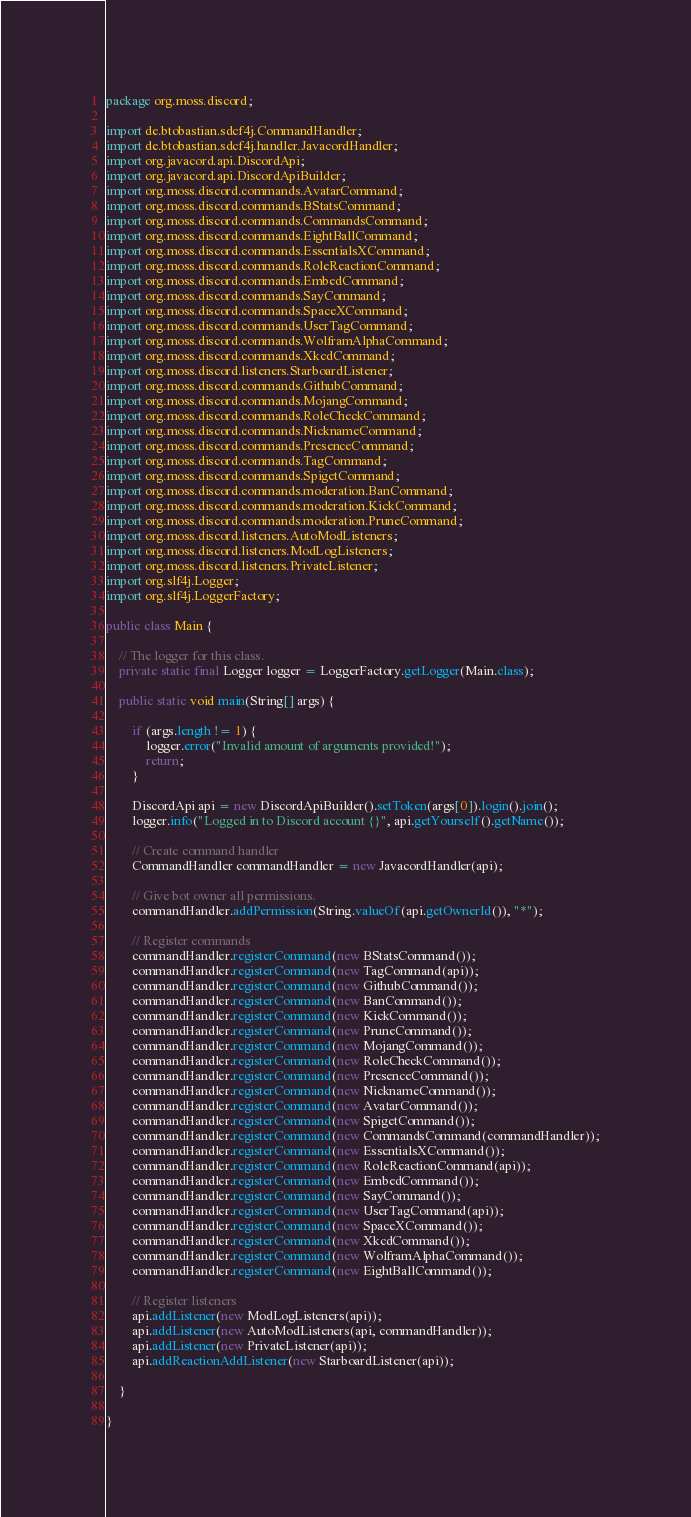Convert code to text. <code><loc_0><loc_0><loc_500><loc_500><_Java_>package org.moss.discord;

import de.btobastian.sdcf4j.CommandHandler;
import de.btobastian.sdcf4j.handler.JavacordHandler;
import org.javacord.api.DiscordApi;
import org.javacord.api.DiscordApiBuilder;
import org.moss.discord.commands.AvatarCommand;
import org.moss.discord.commands.BStatsCommand;
import org.moss.discord.commands.CommandsCommand;
import org.moss.discord.commands.EightBallCommand;
import org.moss.discord.commands.EssentialsXCommand;
import org.moss.discord.commands.RoleReactionCommand;
import org.moss.discord.commands.EmbedCommand;
import org.moss.discord.commands.SayCommand;
import org.moss.discord.commands.SpaceXCommand;
import org.moss.discord.commands.UserTagCommand;
import org.moss.discord.commands.WolframAlphaCommand;
import org.moss.discord.commands.XkcdCommand;
import org.moss.discord.listeners.StarboardListener;
import org.moss.discord.commands.GithubCommand;
import org.moss.discord.commands.MojangCommand;
import org.moss.discord.commands.RoleCheckCommand;
import org.moss.discord.commands.NicknameCommand;
import org.moss.discord.commands.PresenceCommand;
import org.moss.discord.commands.TagCommand;
import org.moss.discord.commands.SpigetCommand;
import org.moss.discord.commands.moderation.BanCommand;
import org.moss.discord.commands.moderation.KickCommand;
import org.moss.discord.commands.moderation.PruneCommand;
import org.moss.discord.listeners.AutoModListeners;
import org.moss.discord.listeners.ModLogListeners;
import org.moss.discord.listeners.PrivateListener;
import org.slf4j.Logger;
import org.slf4j.LoggerFactory;

public class Main {

    // The logger for this class.
    private static final Logger logger = LoggerFactory.getLogger(Main.class);

    public static void main(String[] args) {

        if (args.length != 1) {
            logger.error("Invalid amount of arguments provided!");
            return;
        }

        DiscordApi api = new DiscordApiBuilder().setToken(args[0]).login().join();
        logger.info("Logged in to Discord account {}", api.getYourself().getName());

        // Create command handler
        CommandHandler commandHandler = new JavacordHandler(api);

        // Give bot owner all permissions.
        commandHandler.addPermission(String.valueOf(api.getOwnerId()), "*");

        // Register commands
        commandHandler.registerCommand(new BStatsCommand());
        commandHandler.registerCommand(new TagCommand(api));
        commandHandler.registerCommand(new GithubCommand());
        commandHandler.registerCommand(new BanCommand());
        commandHandler.registerCommand(new KickCommand());
        commandHandler.registerCommand(new PruneCommand());
        commandHandler.registerCommand(new MojangCommand());
        commandHandler.registerCommand(new RoleCheckCommand());
        commandHandler.registerCommand(new PresenceCommand());
        commandHandler.registerCommand(new NicknameCommand());
        commandHandler.registerCommand(new AvatarCommand());
        commandHandler.registerCommand(new SpigetCommand());
        commandHandler.registerCommand(new CommandsCommand(commandHandler));
        commandHandler.registerCommand(new EssentialsXCommand());
        commandHandler.registerCommand(new RoleReactionCommand(api));
        commandHandler.registerCommand(new EmbedCommand());
        commandHandler.registerCommand(new SayCommand());
        commandHandler.registerCommand(new UserTagCommand(api));
        commandHandler.registerCommand(new SpaceXCommand());
        commandHandler.registerCommand(new XkcdCommand());
        commandHandler.registerCommand(new WolframAlphaCommand());
        commandHandler.registerCommand(new EightBallCommand());

        // Register listeners
        api.addListener(new ModLogListeners(api));
        api.addListener(new AutoModListeners(api, commandHandler));
        api.addListener(new PrivateListener(api));
        api.addReactionAddListener(new StarboardListener(api));

    }

}
</code> 